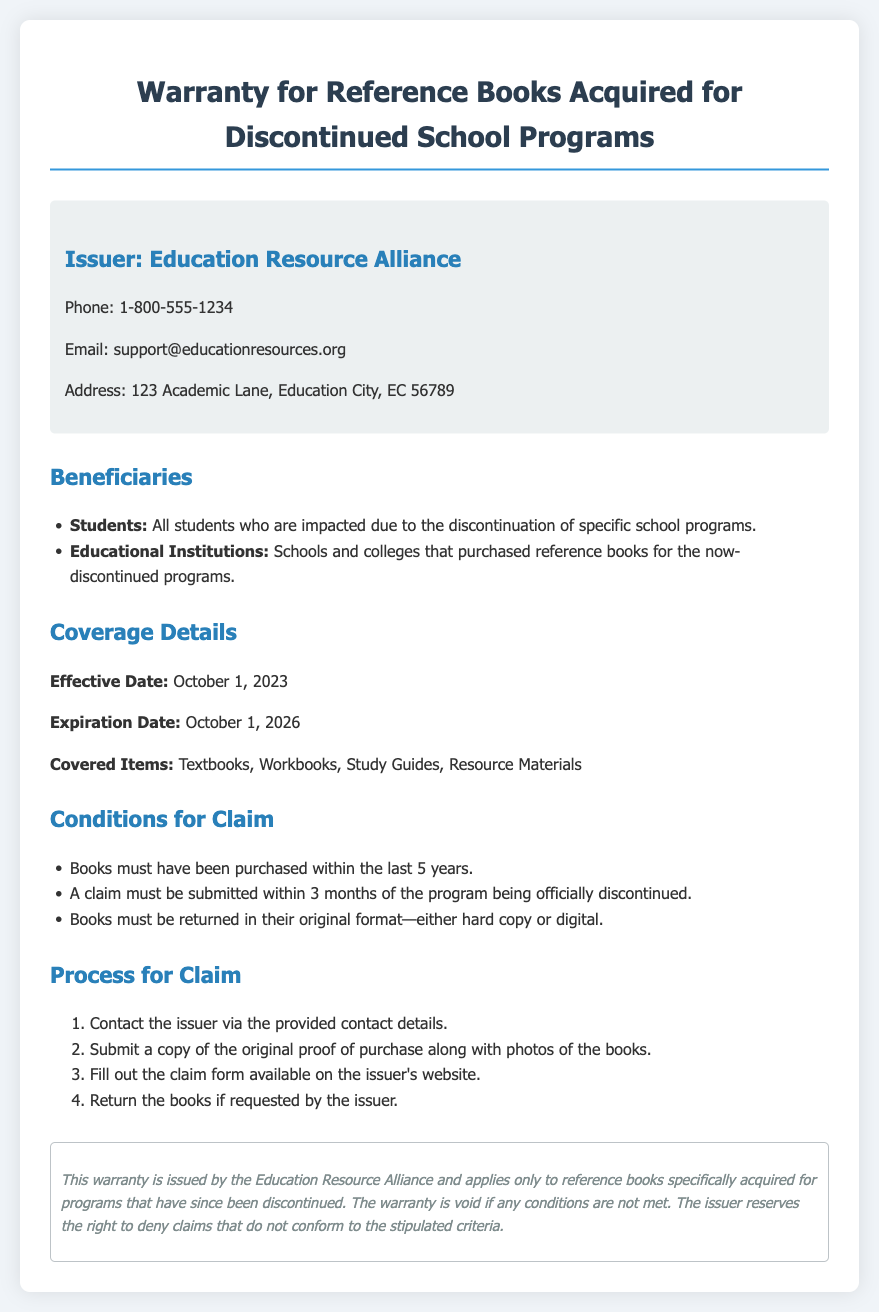What is the issuer's name? The issuer's name is presented at the top of the document, stating the organization responsible for the warranty.
Answer: Education Resource Alliance What is the effective date of the warranty? The effective date is specified in the coverage details section of the document, indicating when the warranty starts.
Answer: October 1, 2023 What items are covered under this warranty? The document lists specific types of books that the warranty covers in the coverage details section.
Answer: Textbooks, Workbooks, Study Guides, Resource Materials How long is the warranty valid? The expiration date in the coverage details specifies the duration of the warranty from the effective date.
Answer: October 1, 2026 What is the claim submission time frame? The conditions for claim section details how long after the program discontinuation claims can be submitted.
Answer: 3 months What is one condition for making a claim? The conditions section outlines specific requirements that must be met for claims, one of which must be stated.
Answer: Books must have been purchased within the last 5 years What must be included with the claim submission? The process for claiming states that certain documents must be submitted to the issuer when making a claim.
Answer: Proof of purchase and photos of the books What happens to the warranty if conditions are not met? The disclaimer at the end mentions the outcome if the stipulated conditions are not adhered to.
Answer: The warranty is void What should be done if books need to be returned? The process for claim section indicates the actions that may be required if the issuer requests the return of books.
Answer: Return the books if requested by the issuer 